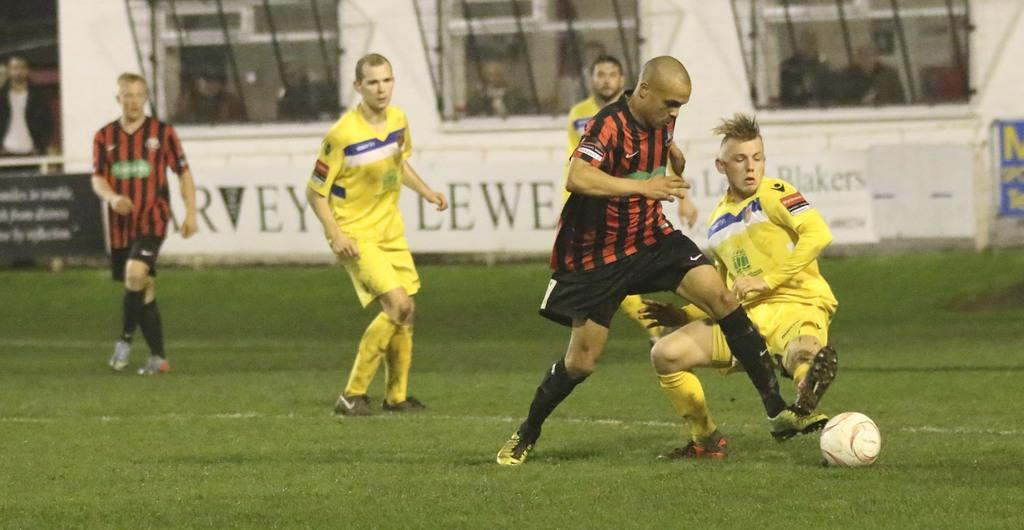<image>
Render a clear and concise summary of the photo. Several advertisements are posted during a soccer game, one was for Blakers 